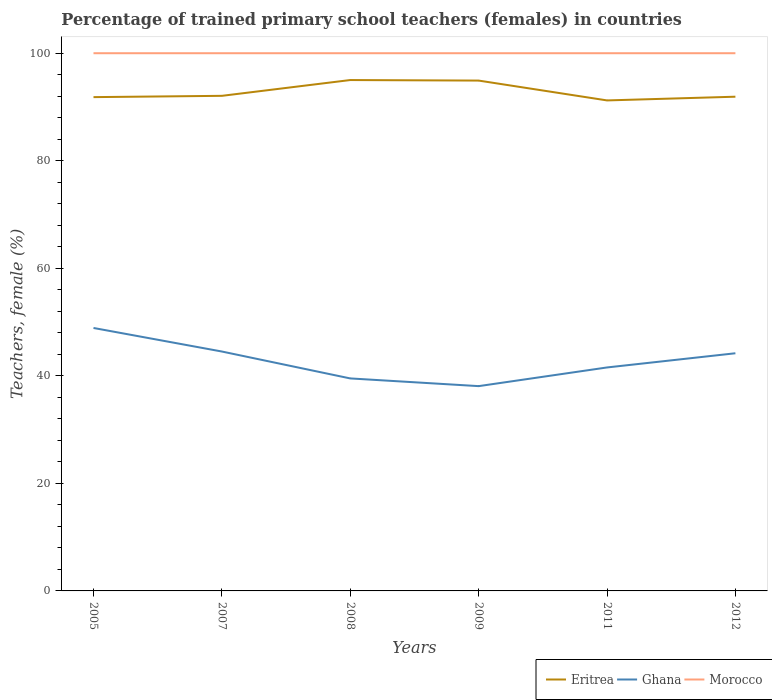Does the line corresponding to Morocco intersect with the line corresponding to Eritrea?
Make the answer very short. No. Is the number of lines equal to the number of legend labels?
Offer a terse response. Yes. Across all years, what is the maximum percentage of trained primary school teachers (females) in Morocco?
Ensure brevity in your answer.  100. In which year was the percentage of trained primary school teachers (females) in Ghana maximum?
Make the answer very short. 2009. What is the total percentage of trained primary school teachers (females) in Morocco in the graph?
Your answer should be compact. 0. What is the difference between the highest and the second highest percentage of trained primary school teachers (females) in Ghana?
Provide a short and direct response. 10.82. What is the difference between the highest and the lowest percentage of trained primary school teachers (females) in Eritrea?
Provide a short and direct response. 2. Is the percentage of trained primary school teachers (females) in Eritrea strictly greater than the percentage of trained primary school teachers (females) in Ghana over the years?
Give a very brief answer. No. How many lines are there?
Provide a short and direct response. 3. How many years are there in the graph?
Keep it short and to the point. 6. Does the graph contain grids?
Your answer should be very brief. No. What is the title of the graph?
Provide a short and direct response. Percentage of trained primary school teachers (females) in countries. Does "Argentina" appear as one of the legend labels in the graph?
Offer a very short reply. No. What is the label or title of the Y-axis?
Make the answer very short. Teachers, female (%). What is the Teachers, female (%) of Eritrea in 2005?
Ensure brevity in your answer.  91.83. What is the Teachers, female (%) in Ghana in 2005?
Offer a terse response. 48.9. What is the Teachers, female (%) of Morocco in 2005?
Make the answer very short. 100. What is the Teachers, female (%) in Eritrea in 2007?
Offer a terse response. 92.08. What is the Teachers, female (%) in Ghana in 2007?
Offer a very short reply. 44.52. What is the Teachers, female (%) of Eritrea in 2008?
Your answer should be compact. 95.01. What is the Teachers, female (%) in Ghana in 2008?
Make the answer very short. 39.52. What is the Teachers, female (%) of Eritrea in 2009?
Provide a short and direct response. 94.91. What is the Teachers, female (%) in Ghana in 2009?
Ensure brevity in your answer.  38.09. What is the Teachers, female (%) in Eritrea in 2011?
Your answer should be very brief. 91.22. What is the Teachers, female (%) of Ghana in 2011?
Provide a succinct answer. 41.56. What is the Teachers, female (%) of Eritrea in 2012?
Your answer should be compact. 91.91. What is the Teachers, female (%) of Ghana in 2012?
Ensure brevity in your answer.  44.2. Across all years, what is the maximum Teachers, female (%) in Eritrea?
Offer a very short reply. 95.01. Across all years, what is the maximum Teachers, female (%) in Ghana?
Your answer should be compact. 48.9. Across all years, what is the maximum Teachers, female (%) in Morocco?
Ensure brevity in your answer.  100. Across all years, what is the minimum Teachers, female (%) of Eritrea?
Provide a short and direct response. 91.22. Across all years, what is the minimum Teachers, female (%) in Ghana?
Provide a succinct answer. 38.09. What is the total Teachers, female (%) of Eritrea in the graph?
Offer a terse response. 556.97. What is the total Teachers, female (%) of Ghana in the graph?
Offer a terse response. 256.79. What is the total Teachers, female (%) in Morocco in the graph?
Your response must be concise. 600. What is the difference between the Teachers, female (%) of Eritrea in 2005 and that in 2007?
Offer a terse response. -0.24. What is the difference between the Teachers, female (%) of Ghana in 2005 and that in 2007?
Your answer should be compact. 4.38. What is the difference between the Teachers, female (%) in Morocco in 2005 and that in 2007?
Provide a succinct answer. 0. What is the difference between the Teachers, female (%) of Eritrea in 2005 and that in 2008?
Offer a very short reply. -3.18. What is the difference between the Teachers, female (%) in Ghana in 2005 and that in 2008?
Offer a terse response. 9.38. What is the difference between the Teachers, female (%) in Eritrea in 2005 and that in 2009?
Offer a very short reply. -3.08. What is the difference between the Teachers, female (%) in Ghana in 2005 and that in 2009?
Your answer should be compact. 10.82. What is the difference between the Teachers, female (%) in Morocco in 2005 and that in 2009?
Your answer should be compact. 0. What is the difference between the Teachers, female (%) of Eritrea in 2005 and that in 2011?
Your response must be concise. 0.61. What is the difference between the Teachers, female (%) of Ghana in 2005 and that in 2011?
Provide a succinct answer. 7.34. What is the difference between the Teachers, female (%) in Eritrea in 2005 and that in 2012?
Provide a short and direct response. -0.08. What is the difference between the Teachers, female (%) in Ghana in 2005 and that in 2012?
Offer a terse response. 4.7. What is the difference between the Teachers, female (%) in Morocco in 2005 and that in 2012?
Give a very brief answer. 0. What is the difference between the Teachers, female (%) of Eritrea in 2007 and that in 2008?
Make the answer very short. -2.94. What is the difference between the Teachers, female (%) in Ghana in 2007 and that in 2008?
Provide a short and direct response. 5. What is the difference between the Teachers, female (%) of Morocco in 2007 and that in 2008?
Keep it short and to the point. 0. What is the difference between the Teachers, female (%) of Eritrea in 2007 and that in 2009?
Make the answer very short. -2.84. What is the difference between the Teachers, female (%) in Ghana in 2007 and that in 2009?
Your response must be concise. 6.44. What is the difference between the Teachers, female (%) of Morocco in 2007 and that in 2009?
Your answer should be compact. 0. What is the difference between the Teachers, female (%) in Eritrea in 2007 and that in 2011?
Offer a very short reply. 0.85. What is the difference between the Teachers, female (%) in Ghana in 2007 and that in 2011?
Your response must be concise. 2.96. What is the difference between the Teachers, female (%) of Eritrea in 2007 and that in 2012?
Provide a short and direct response. 0.16. What is the difference between the Teachers, female (%) of Ghana in 2007 and that in 2012?
Offer a terse response. 0.32. What is the difference between the Teachers, female (%) of Eritrea in 2008 and that in 2009?
Make the answer very short. 0.1. What is the difference between the Teachers, female (%) in Ghana in 2008 and that in 2009?
Your answer should be very brief. 1.43. What is the difference between the Teachers, female (%) in Eritrea in 2008 and that in 2011?
Your answer should be very brief. 3.79. What is the difference between the Teachers, female (%) in Ghana in 2008 and that in 2011?
Make the answer very short. -2.04. What is the difference between the Teachers, female (%) of Morocco in 2008 and that in 2011?
Keep it short and to the point. 0. What is the difference between the Teachers, female (%) of Eritrea in 2008 and that in 2012?
Your response must be concise. 3.1. What is the difference between the Teachers, female (%) in Ghana in 2008 and that in 2012?
Your answer should be compact. -4.68. What is the difference between the Teachers, female (%) of Eritrea in 2009 and that in 2011?
Make the answer very short. 3.69. What is the difference between the Teachers, female (%) of Ghana in 2009 and that in 2011?
Ensure brevity in your answer.  -3.47. What is the difference between the Teachers, female (%) of Eritrea in 2009 and that in 2012?
Your answer should be compact. 3. What is the difference between the Teachers, female (%) in Ghana in 2009 and that in 2012?
Your answer should be compact. -6.11. What is the difference between the Teachers, female (%) of Morocco in 2009 and that in 2012?
Your response must be concise. 0. What is the difference between the Teachers, female (%) of Eritrea in 2011 and that in 2012?
Ensure brevity in your answer.  -0.69. What is the difference between the Teachers, female (%) of Ghana in 2011 and that in 2012?
Your answer should be very brief. -2.64. What is the difference between the Teachers, female (%) of Morocco in 2011 and that in 2012?
Ensure brevity in your answer.  0. What is the difference between the Teachers, female (%) of Eritrea in 2005 and the Teachers, female (%) of Ghana in 2007?
Your answer should be very brief. 47.31. What is the difference between the Teachers, female (%) of Eritrea in 2005 and the Teachers, female (%) of Morocco in 2007?
Ensure brevity in your answer.  -8.17. What is the difference between the Teachers, female (%) in Ghana in 2005 and the Teachers, female (%) in Morocco in 2007?
Give a very brief answer. -51.1. What is the difference between the Teachers, female (%) of Eritrea in 2005 and the Teachers, female (%) of Ghana in 2008?
Provide a succinct answer. 52.31. What is the difference between the Teachers, female (%) of Eritrea in 2005 and the Teachers, female (%) of Morocco in 2008?
Offer a very short reply. -8.17. What is the difference between the Teachers, female (%) in Ghana in 2005 and the Teachers, female (%) in Morocco in 2008?
Offer a very short reply. -51.1. What is the difference between the Teachers, female (%) of Eritrea in 2005 and the Teachers, female (%) of Ghana in 2009?
Your answer should be very brief. 53.75. What is the difference between the Teachers, female (%) of Eritrea in 2005 and the Teachers, female (%) of Morocco in 2009?
Offer a very short reply. -8.17. What is the difference between the Teachers, female (%) in Ghana in 2005 and the Teachers, female (%) in Morocco in 2009?
Provide a short and direct response. -51.1. What is the difference between the Teachers, female (%) in Eritrea in 2005 and the Teachers, female (%) in Ghana in 2011?
Offer a terse response. 50.27. What is the difference between the Teachers, female (%) of Eritrea in 2005 and the Teachers, female (%) of Morocco in 2011?
Keep it short and to the point. -8.17. What is the difference between the Teachers, female (%) in Ghana in 2005 and the Teachers, female (%) in Morocco in 2011?
Offer a terse response. -51.1. What is the difference between the Teachers, female (%) in Eritrea in 2005 and the Teachers, female (%) in Ghana in 2012?
Your answer should be compact. 47.63. What is the difference between the Teachers, female (%) of Eritrea in 2005 and the Teachers, female (%) of Morocco in 2012?
Your response must be concise. -8.17. What is the difference between the Teachers, female (%) of Ghana in 2005 and the Teachers, female (%) of Morocco in 2012?
Offer a very short reply. -51.1. What is the difference between the Teachers, female (%) of Eritrea in 2007 and the Teachers, female (%) of Ghana in 2008?
Your answer should be compact. 52.56. What is the difference between the Teachers, female (%) in Eritrea in 2007 and the Teachers, female (%) in Morocco in 2008?
Ensure brevity in your answer.  -7.92. What is the difference between the Teachers, female (%) in Ghana in 2007 and the Teachers, female (%) in Morocco in 2008?
Keep it short and to the point. -55.48. What is the difference between the Teachers, female (%) in Eritrea in 2007 and the Teachers, female (%) in Ghana in 2009?
Keep it short and to the point. 53.99. What is the difference between the Teachers, female (%) of Eritrea in 2007 and the Teachers, female (%) of Morocco in 2009?
Provide a short and direct response. -7.92. What is the difference between the Teachers, female (%) in Ghana in 2007 and the Teachers, female (%) in Morocco in 2009?
Provide a short and direct response. -55.48. What is the difference between the Teachers, female (%) in Eritrea in 2007 and the Teachers, female (%) in Ghana in 2011?
Your answer should be compact. 50.52. What is the difference between the Teachers, female (%) of Eritrea in 2007 and the Teachers, female (%) of Morocco in 2011?
Keep it short and to the point. -7.92. What is the difference between the Teachers, female (%) in Ghana in 2007 and the Teachers, female (%) in Morocco in 2011?
Offer a terse response. -55.48. What is the difference between the Teachers, female (%) in Eritrea in 2007 and the Teachers, female (%) in Ghana in 2012?
Provide a short and direct response. 47.88. What is the difference between the Teachers, female (%) of Eritrea in 2007 and the Teachers, female (%) of Morocco in 2012?
Give a very brief answer. -7.92. What is the difference between the Teachers, female (%) in Ghana in 2007 and the Teachers, female (%) in Morocco in 2012?
Provide a short and direct response. -55.48. What is the difference between the Teachers, female (%) in Eritrea in 2008 and the Teachers, female (%) in Ghana in 2009?
Ensure brevity in your answer.  56.93. What is the difference between the Teachers, female (%) in Eritrea in 2008 and the Teachers, female (%) in Morocco in 2009?
Make the answer very short. -4.99. What is the difference between the Teachers, female (%) of Ghana in 2008 and the Teachers, female (%) of Morocco in 2009?
Offer a very short reply. -60.48. What is the difference between the Teachers, female (%) in Eritrea in 2008 and the Teachers, female (%) in Ghana in 2011?
Provide a succinct answer. 53.45. What is the difference between the Teachers, female (%) of Eritrea in 2008 and the Teachers, female (%) of Morocco in 2011?
Give a very brief answer. -4.99. What is the difference between the Teachers, female (%) in Ghana in 2008 and the Teachers, female (%) in Morocco in 2011?
Your answer should be compact. -60.48. What is the difference between the Teachers, female (%) of Eritrea in 2008 and the Teachers, female (%) of Ghana in 2012?
Offer a terse response. 50.81. What is the difference between the Teachers, female (%) of Eritrea in 2008 and the Teachers, female (%) of Morocco in 2012?
Provide a short and direct response. -4.99. What is the difference between the Teachers, female (%) in Ghana in 2008 and the Teachers, female (%) in Morocco in 2012?
Your answer should be very brief. -60.48. What is the difference between the Teachers, female (%) in Eritrea in 2009 and the Teachers, female (%) in Ghana in 2011?
Your answer should be very brief. 53.35. What is the difference between the Teachers, female (%) of Eritrea in 2009 and the Teachers, female (%) of Morocco in 2011?
Your answer should be very brief. -5.09. What is the difference between the Teachers, female (%) in Ghana in 2009 and the Teachers, female (%) in Morocco in 2011?
Provide a succinct answer. -61.91. What is the difference between the Teachers, female (%) of Eritrea in 2009 and the Teachers, female (%) of Ghana in 2012?
Your response must be concise. 50.71. What is the difference between the Teachers, female (%) in Eritrea in 2009 and the Teachers, female (%) in Morocco in 2012?
Give a very brief answer. -5.09. What is the difference between the Teachers, female (%) of Ghana in 2009 and the Teachers, female (%) of Morocco in 2012?
Your response must be concise. -61.91. What is the difference between the Teachers, female (%) of Eritrea in 2011 and the Teachers, female (%) of Ghana in 2012?
Your response must be concise. 47.02. What is the difference between the Teachers, female (%) of Eritrea in 2011 and the Teachers, female (%) of Morocco in 2012?
Offer a very short reply. -8.78. What is the difference between the Teachers, female (%) of Ghana in 2011 and the Teachers, female (%) of Morocco in 2012?
Provide a short and direct response. -58.44. What is the average Teachers, female (%) of Eritrea per year?
Offer a terse response. 92.83. What is the average Teachers, female (%) of Ghana per year?
Provide a succinct answer. 42.8. In the year 2005, what is the difference between the Teachers, female (%) in Eritrea and Teachers, female (%) in Ghana?
Your response must be concise. 42.93. In the year 2005, what is the difference between the Teachers, female (%) of Eritrea and Teachers, female (%) of Morocco?
Make the answer very short. -8.17. In the year 2005, what is the difference between the Teachers, female (%) of Ghana and Teachers, female (%) of Morocco?
Provide a succinct answer. -51.1. In the year 2007, what is the difference between the Teachers, female (%) in Eritrea and Teachers, female (%) in Ghana?
Your answer should be compact. 47.55. In the year 2007, what is the difference between the Teachers, female (%) in Eritrea and Teachers, female (%) in Morocco?
Offer a terse response. -7.92. In the year 2007, what is the difference between the Teachers, female (%) of Ghana and Teachers, female (%) of Morocco?
Ensure brevity in your answer.  -55.48. In the year 2008, what is the difference between the Teachers, female (%) in Eritrea and Teachers, female (%) in Ghana?
Give a very brief answer. 55.49. In the year 2008, what is the difference between the Teachers, female (%) in Eritrea and Teachers, female (%) in Morocco?
Your answer should be compact. -4.99. In the year 2008, what is the difference between the Teachers, female (%) of Ghana and Teachers, female (%) of Morocco?
Give a very brief answer. -60.48. In the year 2009, what is the difference between the Teachers, female (%) in Eritrea and Teachers, female (%) in Ghana?
Keep it short and to the point. 56.83. In the year 2009, what is the difference between the Teachers, female (%) in Eritrea and Teachers, female (%) in Morocco?
Provide a short and direct response. -5.09. In the year 2009, what is the difference between the Teachers, female (%) in Ghana and Teachers, female (%) in Morocco?
Your answer should be very brief. -61.91. In the year 2011, what is the difference between the Teachers, female (%) of Eritrea and Teachers, female (%) of Ghana?
Ensure brevity in your answer.  49.66. In the year 2011, what is the difference between the Teachers, female (%) of Eritrea and Teachers, female (%) of Morocco?
Make the answer very short. -8.78. In the year 2011, what is the difference between the Teachers, female (%) in Ghana and Teachers, female (%) in Morocco?
Give a very brief answer. -58.44. In the year 2012, what is the difference between the Teachers, female (%) of Eritrea and Teachers, female (%) of Ghana?
Ensure brevity in your answer.  47.72. In the year 2012, what is the difference between the Teachers, female (%) in Eritrea and Teachers, female (%) in Morocco?
Provide a succinct answer. -8.09. In the year 2012, what is the difference between the Teachers, female (%) in Ghana and Teachers, female (%) in Morocco?
Give a very brief answer. -55.8. What is the ratio of the Teachers, female (%) in Eritrea in 2005 to that in 2007?
Provide a short and direct response. 1. What is the ratio of the Teachers, female (%) of Ghana in 2005 to that in 2007?
Your answer should be compact. 1.1. What is the ratio of the Teachers, female (%) of Eritrea in 2005 to that in 2008?
Provide a short and direct response. 0.97. What is the ratio of the Teachers, female (%) of Ghana in 2005 to that in 2008?
Keep it short and to the point. 1.24. What is the ratio of the Teachers, female (%) in Morocco in 2005 to that in 2008?
Ensure brevity in your answer.  1. What is the ratio of the Teachers, female (%) of Eritrea in 2005 to that in 2009?
Your response must be concise. 0.97. What is the ratio of the Teachers, female (%) of Ghana in 2005 to that in 2009?
Give a very brief answer. 1.28. What is the ratio of the Teachers, female (%) in Eritrea in 2005 to that in 2011?
Your answer should be very brief. 1.01. What is the ratio of the Teachers, female (%) in Ghana in 2005 to that in 2011?
Your answer should be very brief. 1.18. What is the ratio of the Teachers, female (%) of Ghana in 2005 to that in 2012?
Your response must be concise. 1.11. What is the ratio of the Teachers, female (%) in Eritrea in 2007 to that in 2008?
Your answer should be compact. 0.97. What is the ratio of the Teachers, female (%) of Ghana in 2007 to that in 2008?
Your answer should be very brief. 1.13. What is the ratio of the Teachers, female (%) in Morocco in 2007 to that in 2008?
Ensure brevity in your answer.  1. What is the ratio of the Teachers, female (%) in Eritrea in 2007 to that in 2009?
Offer a terse response. 0.97. What is the ratio of the Teachers, female (%) of Ghana in 2007 to that in 2009?
Your response must be concise. 1.17. What is the ratio of the Teachers, female (%) in Morocco in 2007 to that in 2009?
Give a very brief answer. 1. What is the ratio of the Teachers, female (%) of Eritrea in 2007 to that in 2011?
Give a very brief answer. 1.01. What is the ratio of the Teachers, female (%) in Ghana in 2007 to that in 2011?
Your answer should be very brief. 1.07. What is the ratio of the Teachers, female (%) in Eritrea in 2007 to that in 2012?
Ensure brevity in your answer.  1. What is the ratio of the Teachers, female (%) of Ghana in 2007 to that in 2012?
Your response must be concise. 1.01. What is the ratio of the Teachers, female (%) in Eritrea in 2008 to that in 2009?
Your response must be concise. 1. What is the ratio of the Teachers, female (%) in Ghana in 2008 to that in 2009?
Your response must be concise. 1.04. What is the ratio of the Teachers, female (%) of Eritrea in 2008 to that in 2011?
Provide a short and direct response. 1.04. What is the ratio of the Teachers, female (%) of Ghana in 2008 to that in 2011?
Your answer should be very brief. 0.95. What is the ratio of the Teachers, female (%) of Eritrea in 2008 to that in 2012?
Make the answer very short. 1.03. What is the ratio of the Teachers, female (%) of Ghana in 2008 to that in 2012?
Offer a very short reply. 0.89. What is the ratio of the Teachers, female (%) of Eritrea in 2009 to that in 2011?
Your response must be concise. 1.04. What is the ratio of the Teachers, female (%) in Ghana in 2009 to that in 2011?
Offer a terse response. 0.92. What is the ratio of the Teachers, female (%) of Morocco in 2009 to that in 2011?
Your answer should be compact. 1. What is the ratio of the Teachers, female (%) in Eritrea in 2009 to that in 2012?
Offer a very short reply. 1.03. What is the ratio of the Teachers, female (%) in Ghana in 2009 to that in 2012?
Your answer should be very brief. 0.86. What is the ratio of the Teachers, female (%) of Morocco in 2009 to that in 2012?
Your answer should be compact. 1. What is the ratio of the Teachers, female (%) in Eritrea in 2011 to that in 2012?
Ensure brevity in your answer.  0.99. What is the ratio of the Teachers, female (%) of Ghana in 2011 to that in 2012?
Your response must be concise. 0.94. What is the difference between the highest and the second highest Teachers, female (%) of Eritrea?
Give a very brief answer. 0.1. What is the difference between the highest and the second highest Teachers, female (%) of Ghana?
Your response must be concise. 4.38. What is the difference between the highest and the lowest Teachers, female (%) of Eritrea?
Provide a succinct answer. 3.79. What is the difference between the highest and the lowest Teachers, female (%) of Ghana?
Keep it short and to the point. 10.82. 